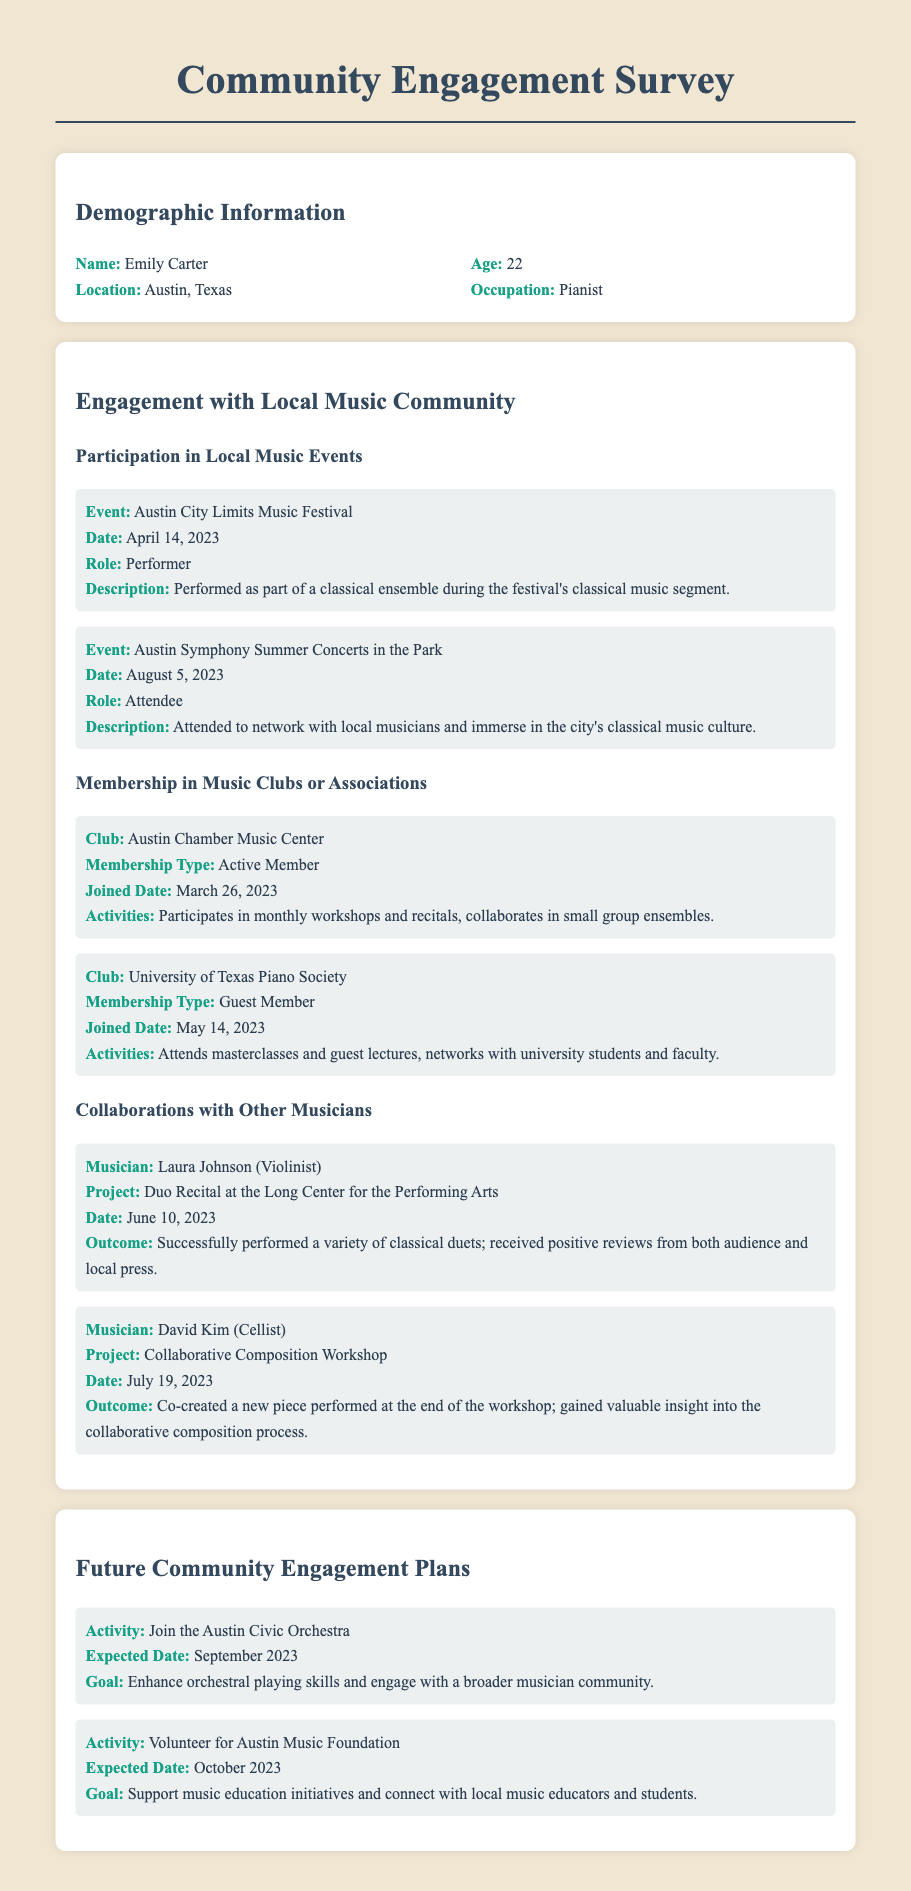What is the name of the young pianist? The name of the young pianist is mentioned in the demographic information section of the document.
Answer: Emily Carter In which city does Emily live? The location is provided in the demographic information section.
Answer: Austin, Texas When did Emily perform at the Austin City Limits Music Festival? The date of the event is specified in the participation details.
Answer: April 14, 2023 What is the membership type for the Austin Chamber Music Center? The membership type is listed under the music clubs section.
Answer: Active Member Who did Emily collaborate with for the duo recital project? The musician involved in the collaboration is detailed in the collaboration section.
Answer: Laura Johnson What is one of Emily's goals for future community engagement? The goals for future activities are outlined in the future community engagement plans.
Answer: Enhance orchestral playing skills How many events did Emily attend in 2023? The number of events can be calculated from the participation information.
Answer: 2 What type of membership does Emily hold in the University of Texas Piano Society? The membership type is provided in the music clubs section of the document.
Answer: Guest Member On what date does Emily plan to join the Austin Civic Orchestra? The expected date for joining is mentioned in the future engagement plans.
Answer: September 2023 